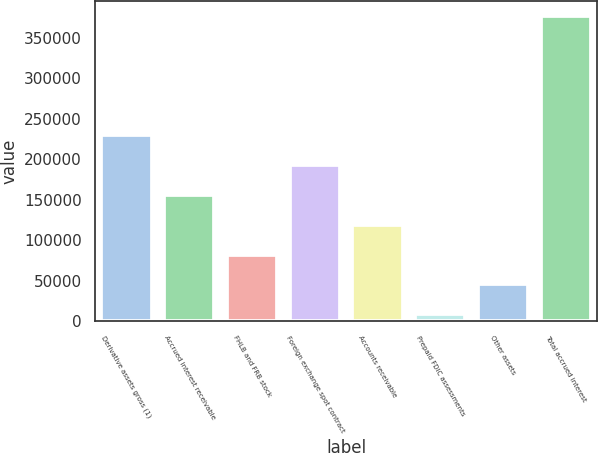Convert chart. <chart><loc_0><loc_0><loc_500><loc_500><bar_chart><fcel>Derivative assets gross (1)<fcel>Accrued interest receivable<fcel>FHLB and FRB stock<fcel>Foreign exchange spot contract<fcel>Accounts receivable<fcel>Prepaid FDIC assessments<fcel>Other assets<fcel>Total accrued interest<nl><fcel>229623<fcel>156007<fcel>82391.6<fcel>192815<fcel>119199<fcel>8776<fcel>45583.8<fcel>376854<nl></chart> 